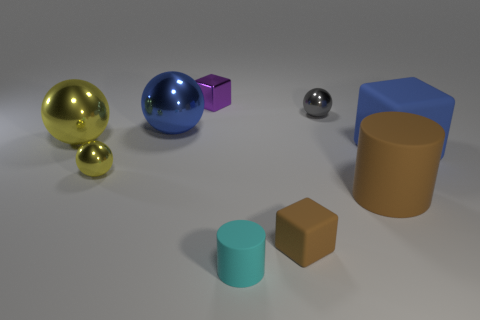Add 1 small brown matte cubes. How many objects exist? 10 Subtract all tiny gray shiny spheres. How many spheres are left? 3 Subtract 3 balls. How many balls are left? 1 Subtract all cyan cylinders. How many cylinders are left? 1 Subtract all cylinders. How many objects are left? 7 Add 7 tiny cylinders. How many tiny cylinders exist? 8 Subtract 1 gray balls. How many objects are left? 8 Subtract all blue cylinders. Subtract all purple blocks. How many cylinders are left? 2 Subtract all red cylinders. How many green blocks are left? 0 Subtract all blocks. Subtract all purple metallic objects. How many objects are left? 5 